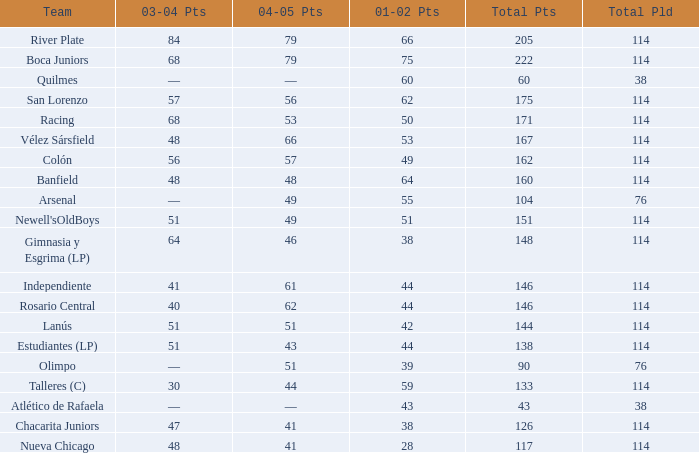Which Total Pts have a 2001–02 Pts smaller than 38? 117.0. 